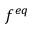<formula> <loc_0><loc_0><loc_500><loc_500>f ^ { e q }</formula> 